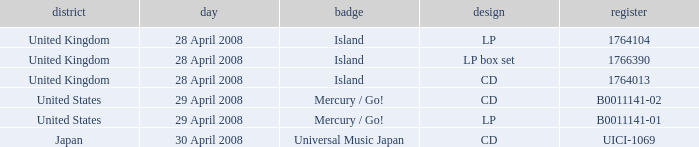What is the Label of the UICI-1069 Catalog? Universal Music Japan. 